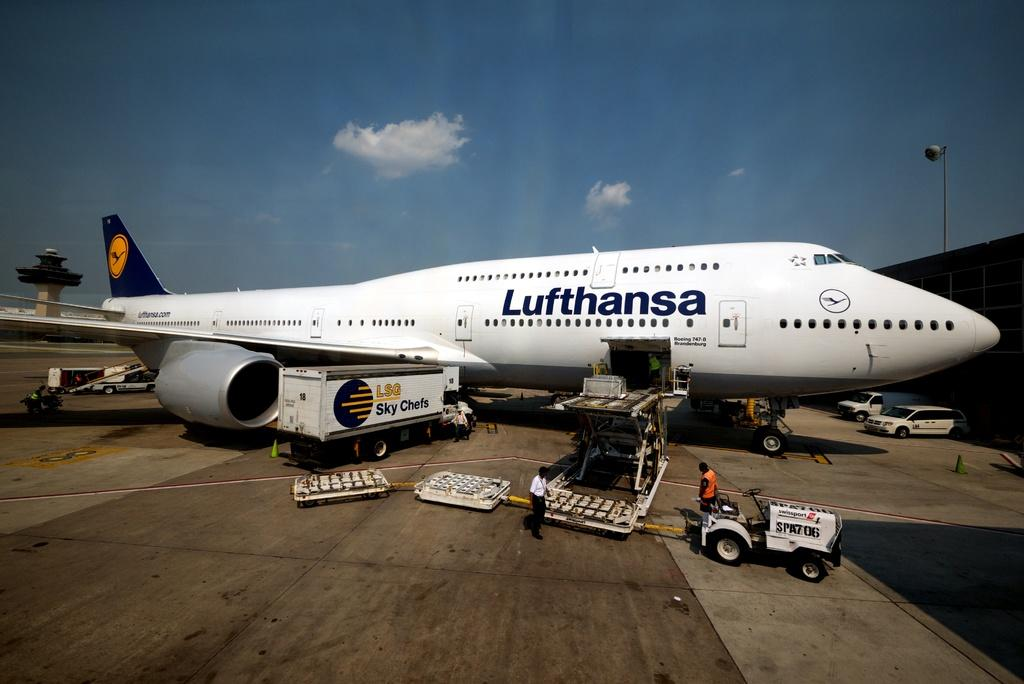<image>
Provide a brief description of the given image. A white Lufthansa airplane sits and a man in an orange vest looks at it. 